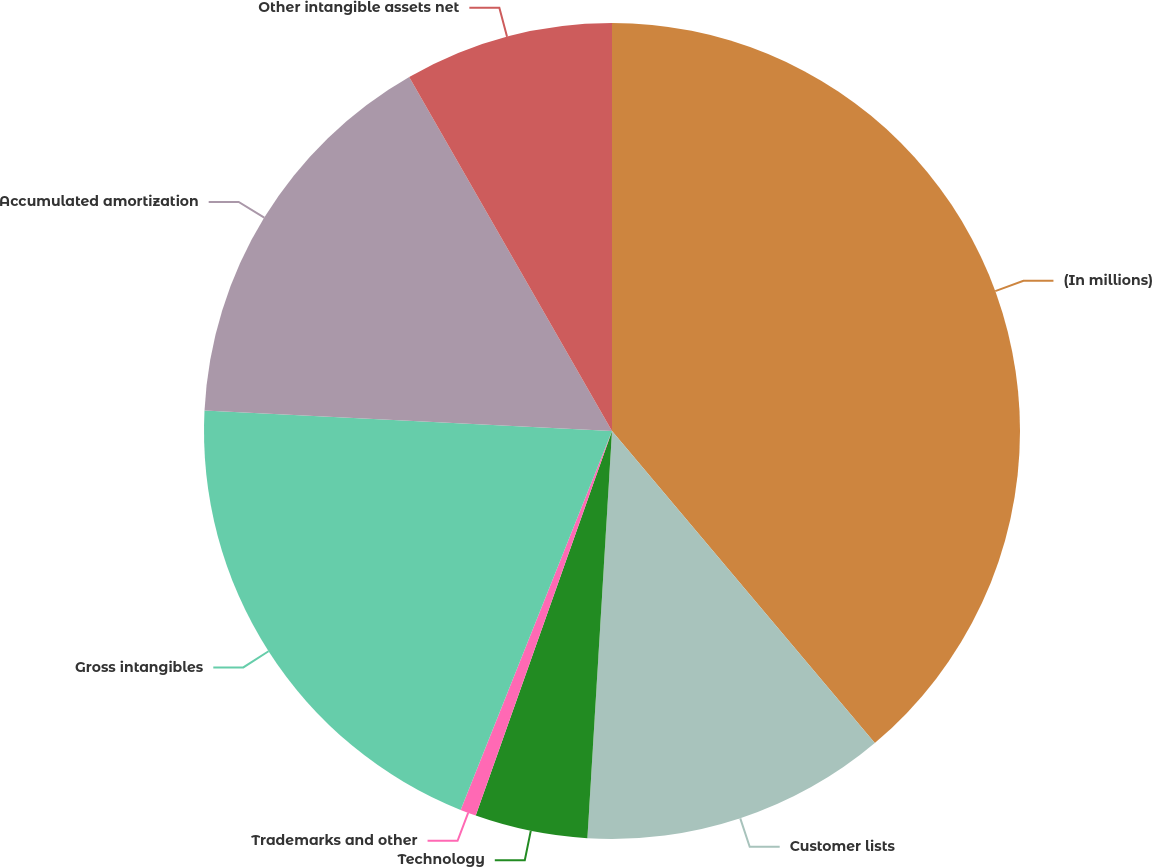<chart> <loc_0><loc_0><loc_500><loc_500><pie_chart><fcel>(In millions)<fcel>Customer lists<fcel>Technology<fcel>Trademarks and other<fcel>Gross intangibles<fcel>Accumulated amortization<fcel>Other intangible assets net<nl><fcel>38.86%<fcel>12.1%<fcel>4.46%<fcel>0.63%<fcel>19.75%<fcel>15.92%<fcel>8.28%<nl></chart> 